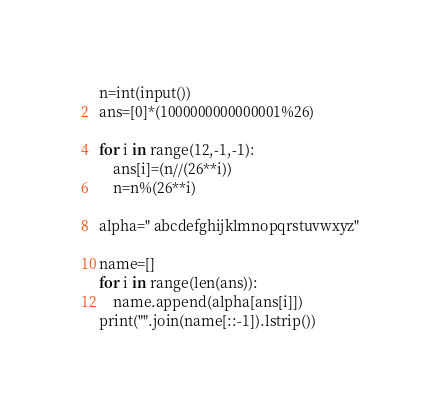<code> <loc_0><loc_0><loc_500><loc_500><_Python_>n=int(input())
ans=[0]*(1000000000000001%26)

for i in range(12,-1,-1):
    ans[i]=(n//(26**i))
    n=n%(26**i)

alpha=" abcdefghijklmnopqrstuvwxyz"

name=[]
for i in range(len(ans)):
    name.append(alpha[ans[i]])
print("".join(name[::-1]).lstrip())

</code> 